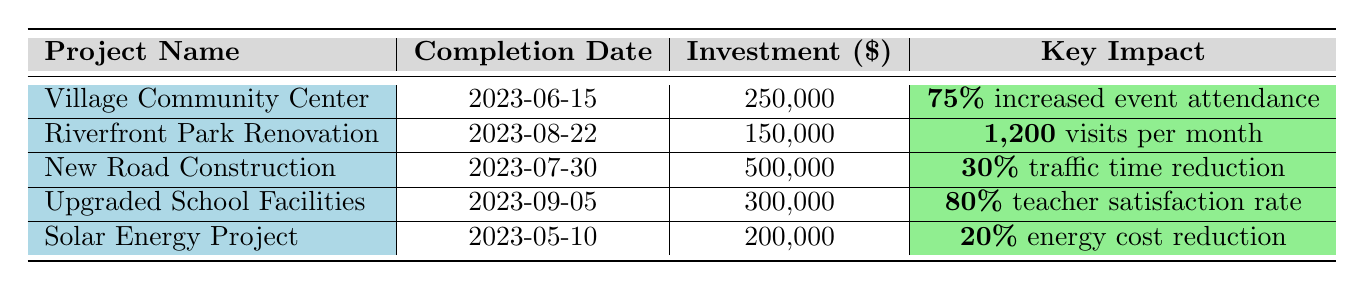What is the investment amount for the New Road Construction project? The table lists the investment amount under the New Road Construction project in the corresponding column, which states 500,000.
Answer: 500,000 How many visits per month are reported for the Riverfront Park Renovation? The table clearly indicates that the Riverfront Park Renovation project has 1,200 visits per month as stated in the key impact column.
Answer: 1,200 Is the teacher satisfaction rate for the Upgraded School Facilities greater than 75%? The table shows the teacher satisfaction rate for the Upgraded School Facilities is 80%, which is indeed greater than 75%.
Answer: Yes What was the total investment amount for all the projects listed? To get the total investment, we sum all individual project investments: 250,000 + 150,000 + 500,000 + 300,000 + 200,000 = 1,400,000.
Answer: 1,400,000 Did the New Road Construction project reduce traffic time by more than 25%? The data shows a traffic time reduction of 30% for the New Road Construction project, which is more than 25%.
Answer: Yes What is the average impact of increased event attendance and youth program participation from the Village Community Center? We calculate the average by summing the increased event attendance (75) and youth program participation (40) and then dividing by 2: (75 + 40)/2 = 57.5.
Answer: 57.5 Which project had the highest investment amount? By comparing the investment amounts listed, the New Road Construction project had the highest investment at 500,000.
Answer: New Road Construction How many more family activities were increased due to the Riverfront Park Renovation compared to the job creation from the Village Community Center? The Riverfront Park Renovation had an increase of 60 family activities and the Village Community Center created 5 jobs, so the difference is 60 - 5 = 55.
Answer: 55 What percentage of energy cost reduction does the Solar Energy Project provide? The Solar Energy Project reports a 20% energy cost reduction, which is stated explicitly under its key impact.
Answer: 20% Based on the impacts listed, which type of project had job creation as a key impact? The only project that lists job creation as a key impact is the Village Community Center, which specifies an increase in job creation by 5.
Answer: Village Community Center 